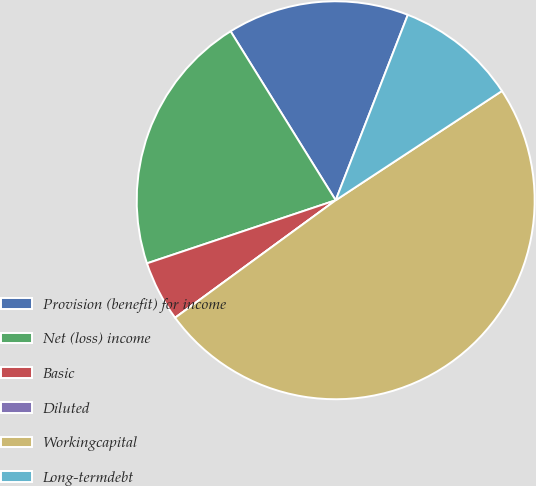<chart> <loc_0><loc_0><loc_500><loc_500><pie_chart><fcel>Provision (benefit) for income<fcel>Net (loss) income<fcel>Basic<fcel>Diluted<fcel>Workingcapital<fcel>Long-termdebt<nl><fcel>14.76%<fcel>21.28%<fcel>4.92%<fcel>0.0%<fcel>49.2%<fcel>9.84%<nl></chart> 